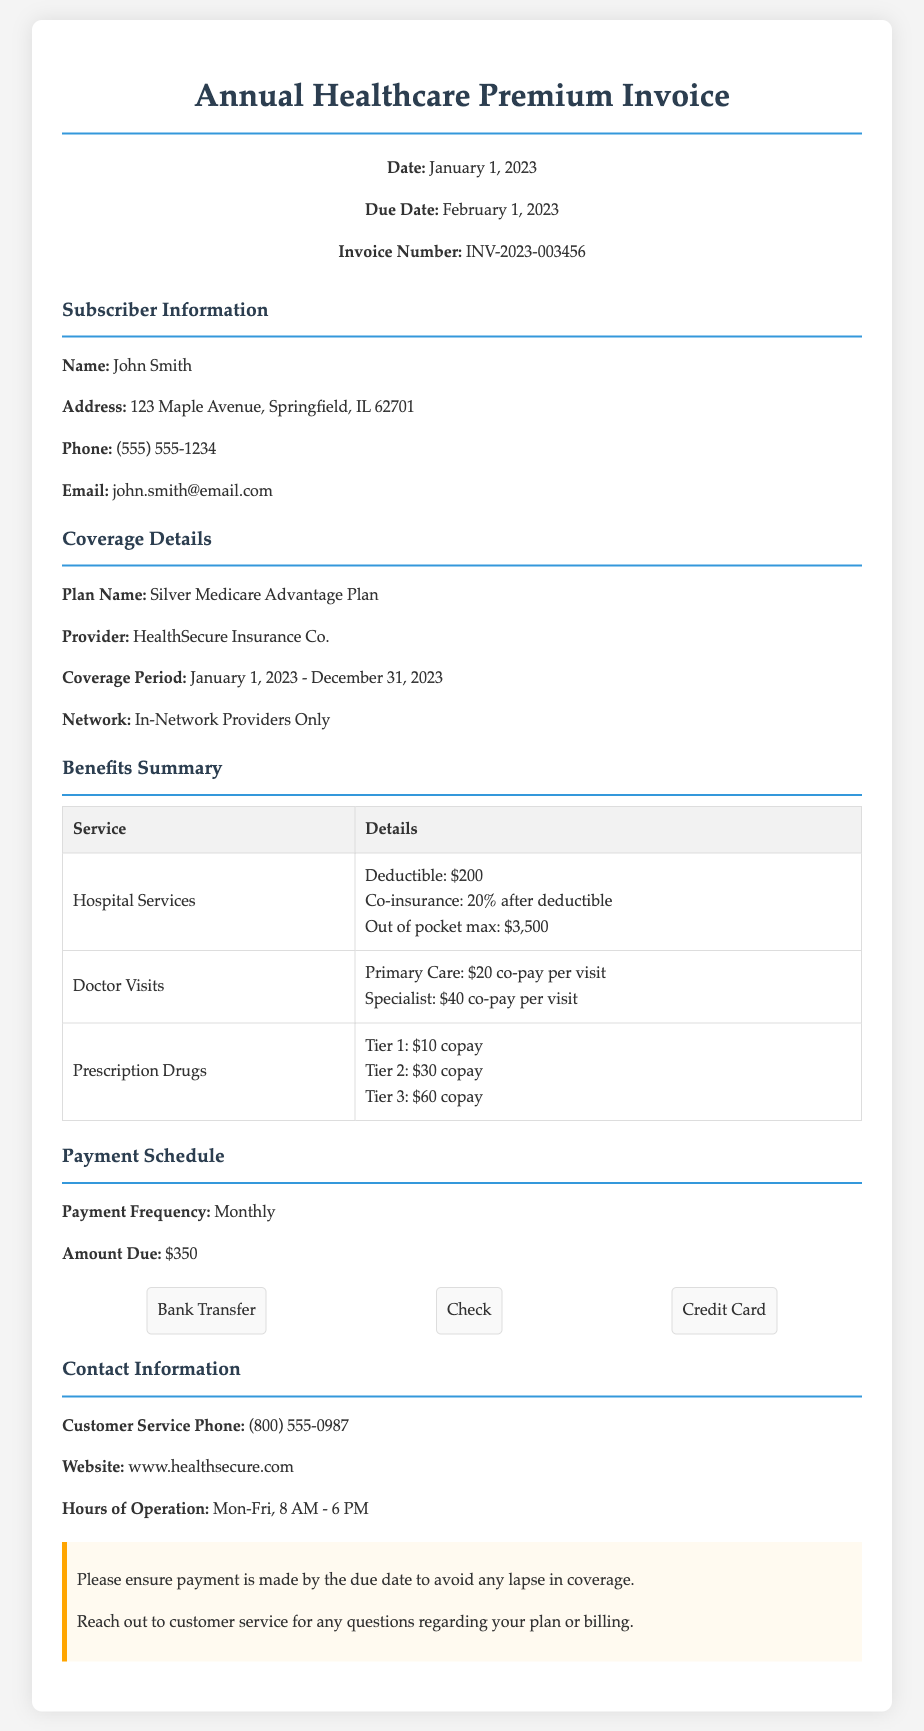What is the invoice number? The invoice number can be found at the top of the document and is specified as INV-2023-003456.
Answer: INV-2023-003456 What is the total monthly premium amount due? The amount due from the payment schedule section states the total monthly premium amount of $350.
Answer: $350 What is the due date for the payment? The due date for the payment is mentioned in the header section as February 1, 2023.
Answer: February 1, 2023 What is the name of the insurance provider? The provider of the plan is listed under coverage details as HealthSecure Insurance Co.
Answer: HealthSecure Insurance Co What is the out-of-pocket maximum for hospital services? The out-of-pocket maximum for hospital services is detailed in the benefits summary and is stated as $3,500.
Answer: $3,500 How often is the payment required? The payment frequency is listed in the payment schedule section, which states it is monthly.
Answer: Monthly What type of plan is this invoice for? The plan name is specified in the coverage details as Silver Medicare Advantage Plan.
Answer: Silver Medicare Advantage Plan What services have a co-pay mentioned? Co-pays are mentioned specifically for Doctor Visits under the benefits summary.
Answer: Doctor Visits What should you ensure to avoid a lapse in coverage? The notice section indicates to ensure payment is made by the due date to avoid lapse in coverage.
Answer: Payment by the due date 